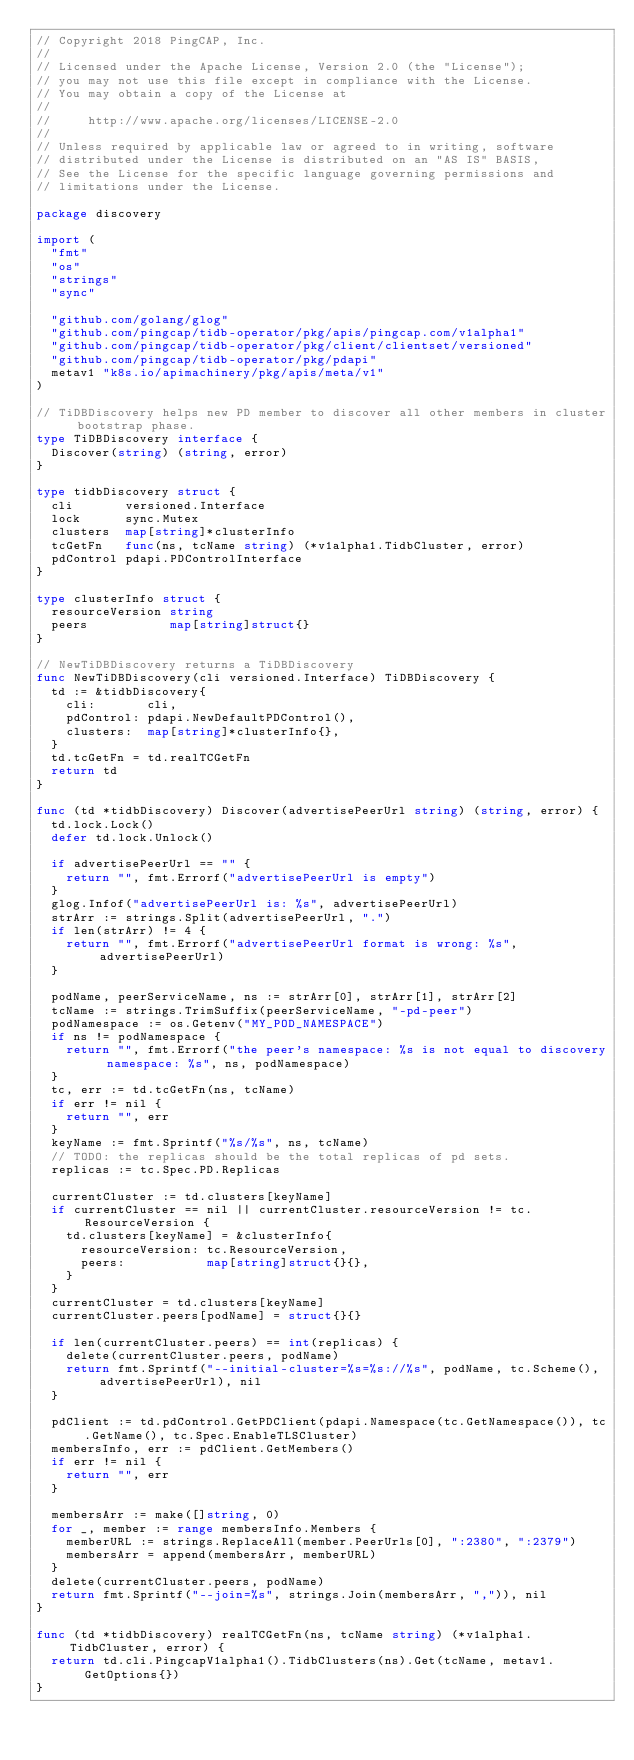Convert code to text. <code><loc_0><loc_0><loc_500><loc_500><_Go_>// Copyright 2018 PingCAP, Inc.
//
// Licensed under the Apache License, Version 2.0 (the "License");
// you may not use this file except in compliance with the License.
// You may obtain a copy of the License at
//
//     http://www.apache.org/licenses/LICENSE-2.0
//
// Unless required by applicable law or agreed to in writing, software
// distributed under the License is distributed on an "AS IS" BASIS,
// See the License for the specific language governing permissions and
// limitations under the License.

package discovery

import (
	"fmt"
	"os"
	"strings"
	"sync"

	"github.com/golang/glog"
	"github.com/pingcap/tidb-operator/pkg/apis/pingcap.com/v1alpha1"
	"github.com/pingcap/tidb-operator/pkg/client/clientset/versioned"
	"github.com/pingcap/tidb-operator/pkg/pdapi"
	metav1 "k8s.io/apimachinery/pkg/apis/meta/v1"
)

// TiDBDiscovery helps new PD member to discover all other members in cluster bootstrap phase.
type TiDBDiscovery interface {
	Discover(string) (string, error)
}

type tidbDiscovery struct {
	cli       versioned.Interface
	lock      sync.Mutex
	clusters  map[string]*clusterInfo
	tcGetFn   func(ns, tcName string) (*v1alpha1.TidbCluster, error)
	pdControl pdapi.PDControlInterface
}

type clusterInfo struct {
	resourceVersion string
	peers           map[string]struct{}
}

// NewTiDBDiscovery returns a TiDBDiscovery
func NewTiDBDiscovery(cli versioned.Interface) TiDBDiscovery {
	td := &tidbDiscovery{
		cli:       cli,
		pdControl: pdapi.NewDefaultPDControl(),
		clusters:  map[string]*clusterInfo{},
	}
	td.tcGetFn = td.realTCGetFn
	return td
}

func (td *tidbDiscovery) Discover(advertisePeerUrl string) (string, error) {
	td.lock.Lock()
	defer td.lock.Unlock()

	if advertisePeerUrl == "" {
		return "", fmt.Errorf("advertisePeerUrl is empty")
	}
	glog.Infof("advertisePeerUrl is: %s", advertisePeerUrl)
	strArr := strings.Split(advertisePeerUrl, ".")
	if len(strArr) != 4 {
		return "", fmt.Errorf("advertisePeerUrl format is wrong: %s", advertisePeerUrl)
	}

	podName, peerServiceName, ns := strArr[0], strArr[1], strArr[2]
	tcName := strings.TrimSuffix(peerServiceName, "-pd-peer")
	podNamespace := os.Getenv("MY_POD_NAMESPACE")
	if ns != podNamespace {
		return "", fmt.Errorf("the peer's namespace: %s is not equal to discovery namespace: %s", ns, podNamespace)
	}
	tc, err := td.tcGetFn(ns, tcName)
	if err != nil {
		return "", err
	}
	keyName := fmt.Sprintf("%s/%s", ns, tcName)
	// TODO: the replicas should be the total replicas of pd sets.
	replicas := tc.Spec.PD.Replicas

	currentCluster := td.clusters[keyName]
	if currentCluster == nil || currentCluster.resourceVersion != tc.ResourceVersion {
		td.clusters[keyName] = &clusterInfo{
			resourceVersion: tc.ResourceVersion,
			peers:           map[string]struct{}{},
		}
	}
	currentCluster = td.clusters[keyName]
	currentCluster.peers[podName] = struct{}{}

	if len(currentCluster.peers) == int(replicas) {
		delete(currentCluster.peers, podName)
		return fmt.Sprintf("--initial-cluster=%s=%s://%s", podName, tc.Scheme(), advertisePeerUrl), nil
	}

	pdClient := td.pdControl.GetPDClient(pdapi.Namespace(tc.GetNamespace()), tc.GetName(), tc.Spec.EnableTLSCluster)
	membersInfo, err := pdClient.GetMembers()
	if err != nil {
		return "", err
	}

	membersArr := make([]string, 0)
	for _, member := range membersInfo.Members {
		memberURL := strings.ReplaceAll(member.PeerUrls[0], ":2380", ":2379")
		membersArr = append(membersArr, memberURL)
	}
	delete(currentCluster.peers, podName)
	return fmt.Sprintf("--join=%s", strings.Join(membersArr, ",")), nil
}

func (td *tidbDiscovery) realTCGetFn(ns, tcName string) (*v1alpha1.TidbCluster, error) {
	return td.cli.PingcapV1alpha1().TidbClusters(ns).Get(tcName, metav1.GetOptions{})
}
</code> 